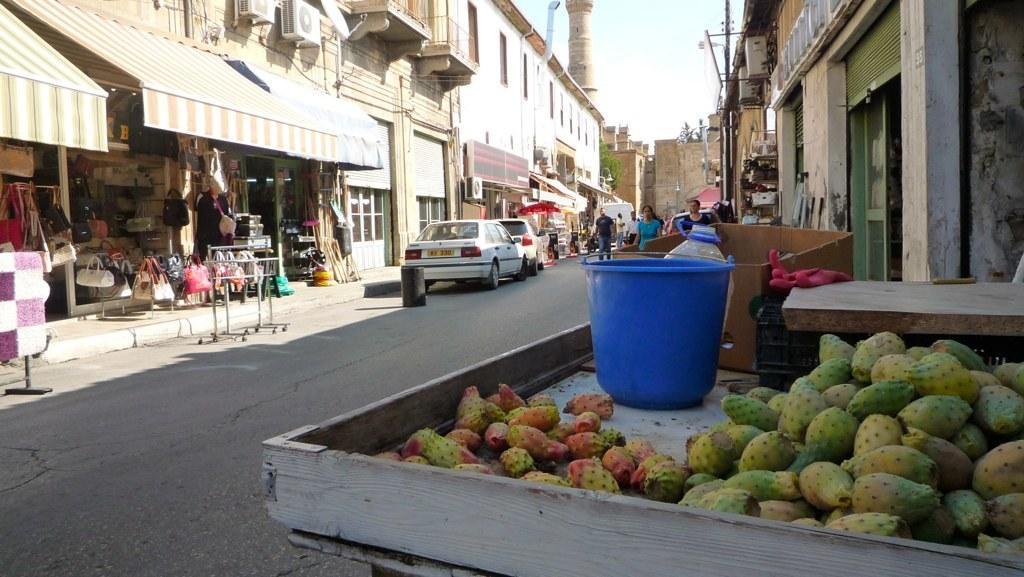Describe this image in one or two sentences. In this image we can see fruits, bucket, can and cardboard box kept on the cart and these people walking on the road and vehicles moving on the road. Here we can a store, tents, building, trees and the sky in the background. 